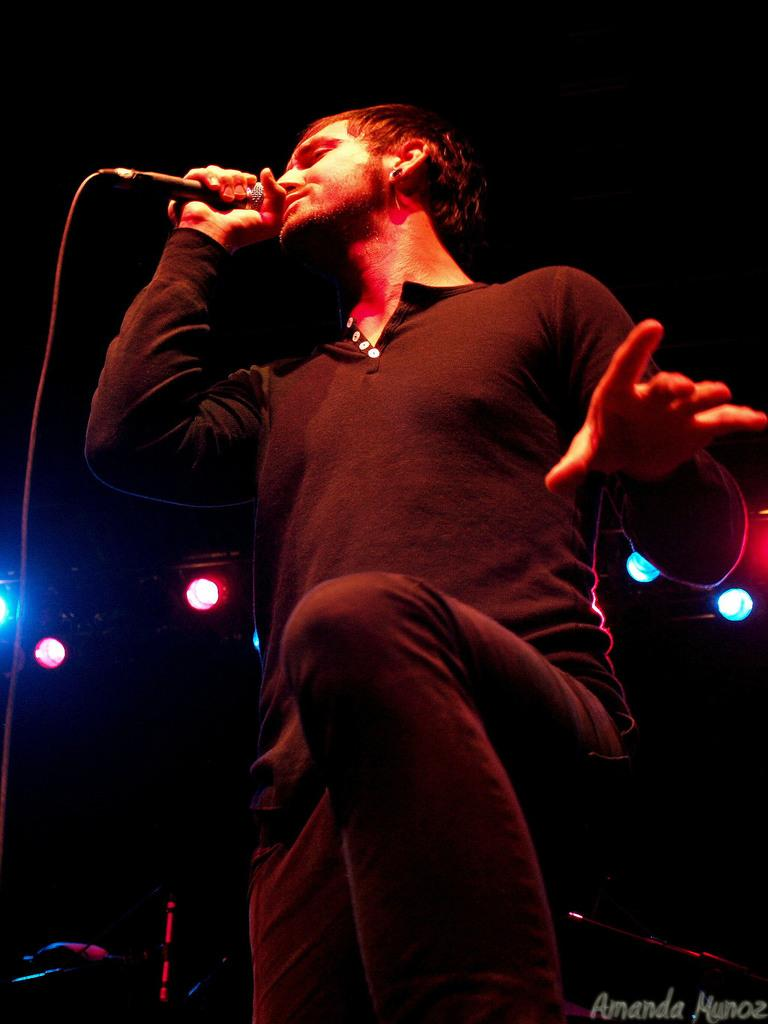What is the man in the image doing? The man is singing a song. What is the man holding while singing? The man is holding a microphone. What is the man wearing in the image? The man is wearing a black T-shirt and black pants. What can be seen in the background of the image? There are lights visible in the background of the image, and the background appears to be dark. What type of desk is visible in the image? There is no desk present in the image. What happens to the lights when the man starts singing? The lights do not change or burst when the man starts singing; they remain visible in the background. 